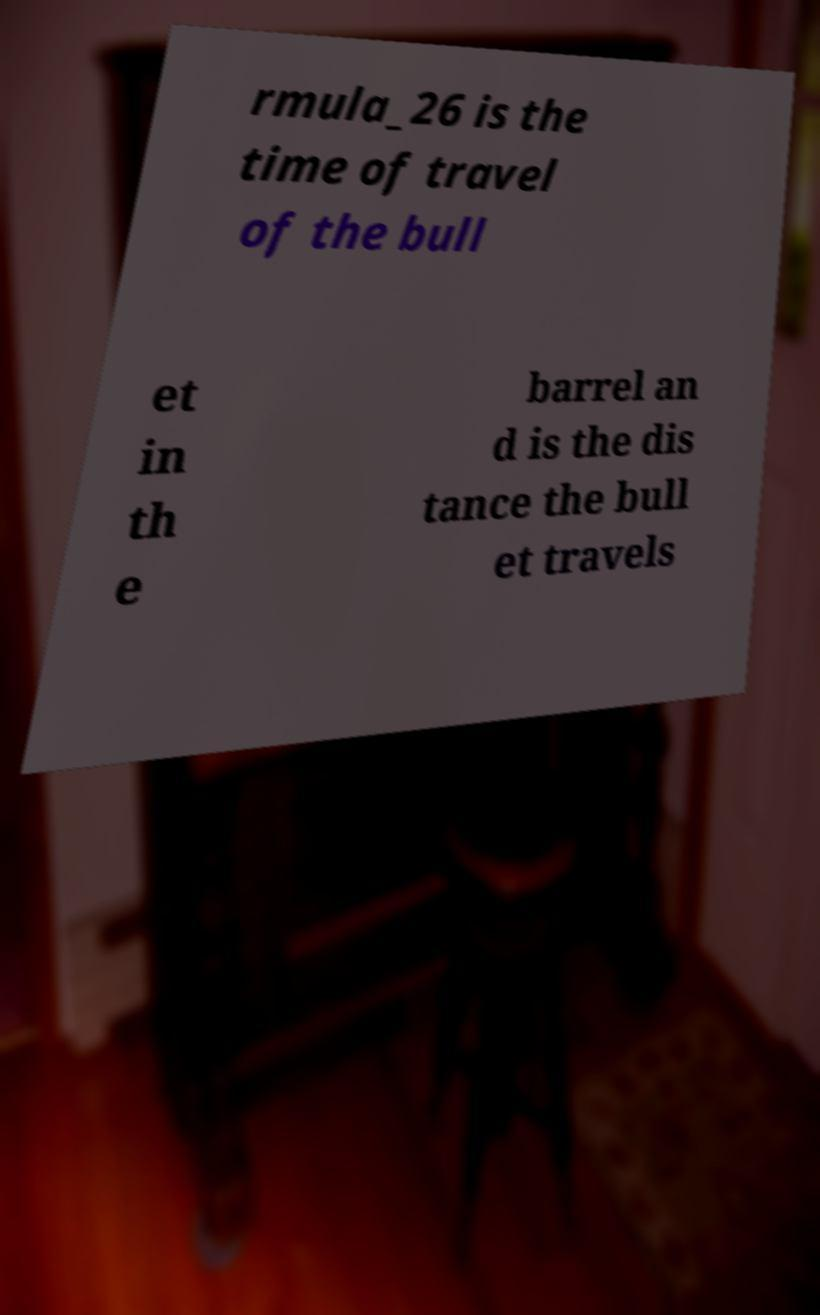Please identify and transcribe the text found in this image. rmula_26 is the time of travel of the bull et in th e barrel an d is the dis tance the bull et travels 